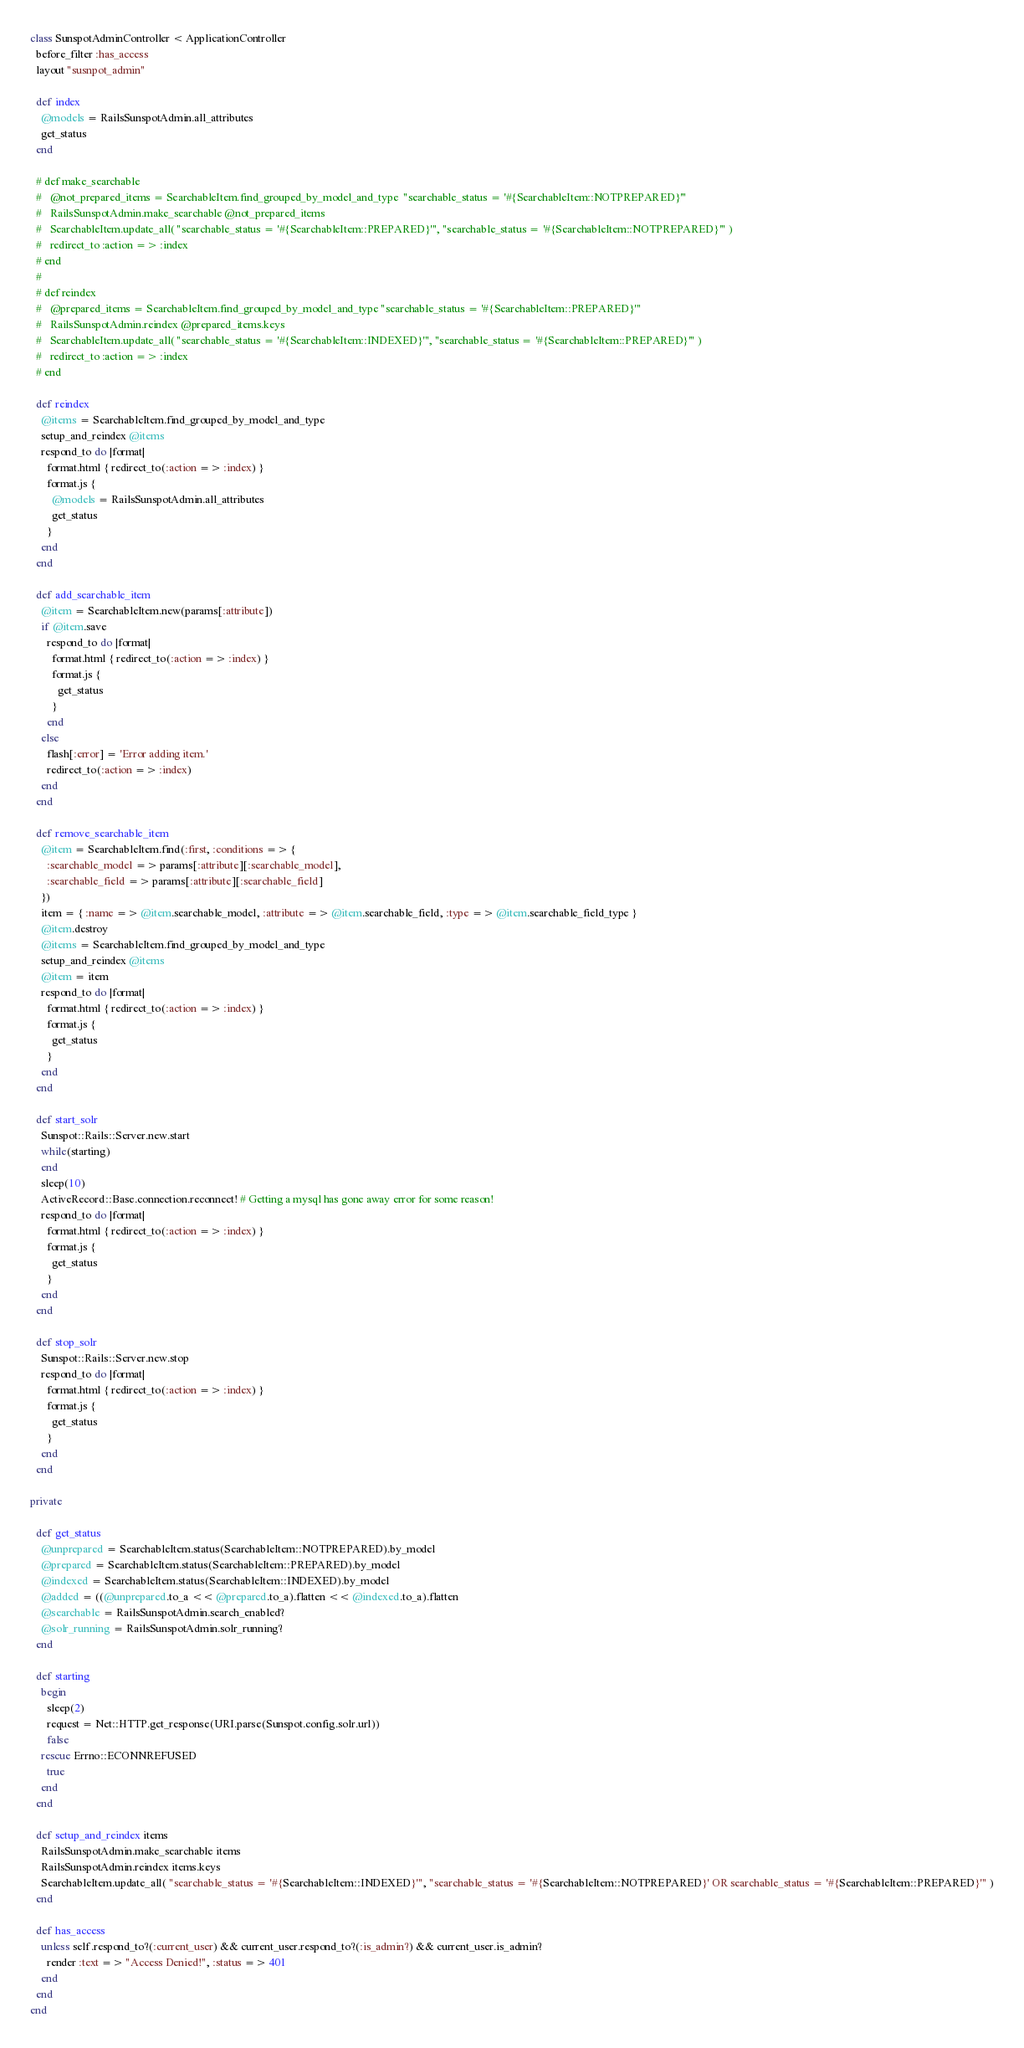Convert code to text. <code><loc_0><loc_0><loc_500><loc_500><_Ruby_>class SunspotAdminController < ApplicationController
  before_filter :has_access
  layout "susnpot_admin"
  
  def index
    @models = RailsSunspotAdmin.all_attributes
    get_status
  end
  
  # def make_searchable
  #   @not_prepared_items = SearchableItem.find_grouped_by_model_and_type  "searchable_status = '#{SearchableItem::NOTPREPARED}'"
  #   RailsSunspotAdmin.make_searchable @not_prepared_items
  #   SearchableItem.update_all( "searchable_status = '#{SearchableItem::PREPARED}'", "searchable_status = '#{SearchableItem::NOTPREPARED}'" )
  #   redirect_to :action => :index
  # end
  # 
  # def reindex
  #   @prepared_items = SearchableItem.find_grouped_by_model_and_type "searchable_status = '#{SearchableItem::PREPARED}'" 
  #   RailsSunspotAdmin.reindex @prepared_items.keys
  #   SearchableItem.update_all( "searchable_status = '#{SearchableItem::INDEXED}'", "searchable_status = '#{SearchableItem::PREPARED}'" )
  #   redirect_to :action => :index
  # end

  def reindex
    @items = SearchableItem.find_grouped_by_model_and_type
    setup_and_reindex @items
    respond_to do |format|
      format.html { redirect_to(:action => :index) }
      format.js {
        @models = RailsSunspotAdmin.all_attributes 
        get_status
      }
    end
  end
  
  def add_searchable_item
    @item = SearchableItem.new(params[:attribute])
    if @item.save
      respond_to do |format|
        format.html { redirect_to(:action => :index) }
        format.js { 
          get_status
        }
      end
    else
      flash[:error] = 'Error adding item.'
      redirect_to(:action => :index)
    end
  end
  
  def remove_searchable_item
    @item = SearchableItem.find(:first, :conditions => { 
      :searchable_model => params[:attribute][:searchable_model], 
      :searchable_field => params[:attribute][:searchable_field]
    })
    item = { :name => @item.searchable_model, :attribute => @item.searchable_field, :type => @item.searchable_field_type }
    @item.destroy
    @items = SearchableItem.find_grouped_by_model_and_type
    setup_and_reindex @items
    @item = item
    respond_to do |format|
      format.html { redirect_to(:action => :index) }
      format.js { 
        get_status
      }
    end
  end
  
  def start_solr
    Sunspot::Rails::Server.new.start
    while(starting)
    end
    sleep(10)
    ActiveRecord::Base.connection.reconnect! # Getting a mysql has gone away error for some reason!
    respond_to do |format|
      format.html { redirect_to(:action => :index) }
      format.js { 
        get_status
      }
    end    
  end
  
  def stop_solr
    Sunspot::Rails::Server.new.stop
    respond_to do |format|
      format.html { redirect_to(:action => :index) }
      format.js { 
        get_status
      }
    end
  end
 
private

  def get_status
    @unprepared = SearchableItem.status(SearchableItem::NOTPREPARED).by_model
    @prepared = SearchableItem.status(SearchableItem::PREPARED).by_model
    @indexed = SearchableItem.status(SearchableItem::INDEXED).by_model
    @added = ((@unprepared.to_a << @prepared.to_a).flatten << @indexed.to_a).flatten
    @searchable = RailsSunspotAdmin.search_enabled?
    @solr_running = RailsSunspotAdmin.solr_running?
  end
  
  def starting
    begin
      sleep(2)
      request = Net::HTTP.get_response(URI.parse(Sunspot.config.solr.url))
      false
    rescue Errno::ECONNREFUSED
      true
    end
  end
  
  def setup_and_reindex items
    RailsSunspotAdmin.make_searchable items
    RailsSunspotAdmin.reindex items.keys
    SearchableItem.update_all( "searchable_status = '#{SearchableItem::INDEXED}'", "searchable_status = '#{SearchableItem::NOTPREPARED}' OR searchable_status = '#{SearchableItem::PREPARED}'" )
  end
  
  def has_access
    unless self.respond_to?(:current_user) && current_user.respond_to?(:is_admin?) && current_user.is_admin?
      render :text => "Access Denied!", :status => 401
    end
  end
end
</code> 